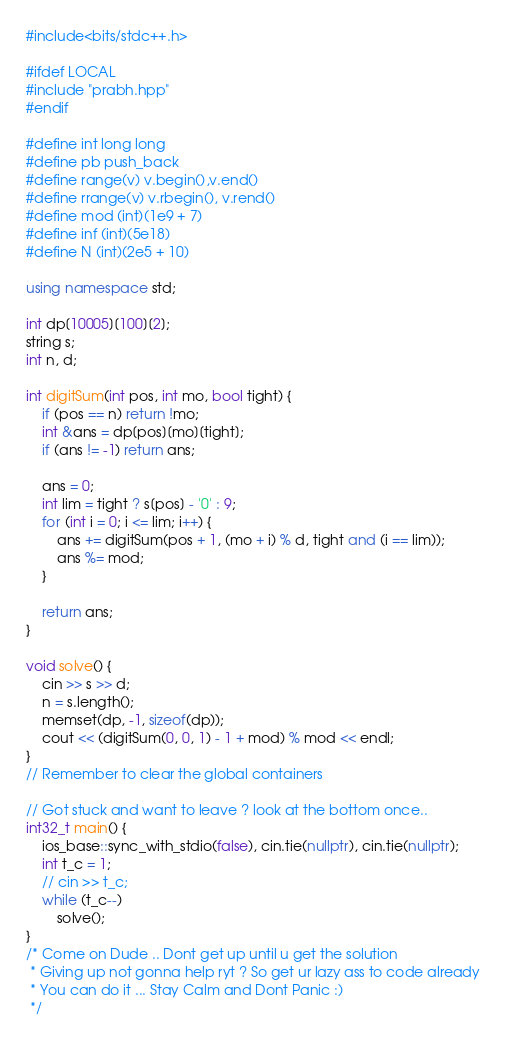<code> <loc_0><loc_0><loc_500><loc_500><_C++_>#include<bits/stdc++.h>

#ifdef LOCAL
#include "prabh.hpp"
#endif

#define int long long
#define pb push_back
#define range(v) v.begin(),v.end()
#define rrange(v) v.rbegin(), v.rend()
#define mod (int)(1e9 + 7)
#define inf (int)(5e18)
#define N (int)(2e5 + 10)

using namespace std;

int dp[10005][100][2];
string s;
int n, d;

int digitSum(int pos, int mo, bool tight) {
	if (pos == n) return !mo;
	int &ans = dp[pos][mo][tight];
	if (ans != -1) return ans;

	ans = 0;
	int lim = tight ? s[pos] - '0' : 9;
	for (int i = 0; i <= lim; i++) {
		ans += digitSum(pos + 1, (mo + i) % d, tight and (i == lim));
		ans %= mod;
	}

	return ans;
}

void solve() {
	cin >> s >> d;
	n = s.length();
	memset(dp, -1, sizeof(dp));
	cout << (digitSum(0, 0, 1) - 1 + mod) % mod << endl;
}
// Remember to clear the global containers

// Got stuck and want to leave ? look at the bottom once..
int32_t main() {
	ios_base::sync_with_stdio(false), cin.tie(nullptr), cin.tie(nullptr);
	int t_c = 1;
	// cin >> t_c;
	while (t_c--)
		solve();
}
/* Come on Dude .. Dont get up until u get the solution
 * Giving up not gonna help ryt ? So get ur lazy ass to code already
 * You can do it ... Stay Calm and Dont Panic :)
 */
</code> 